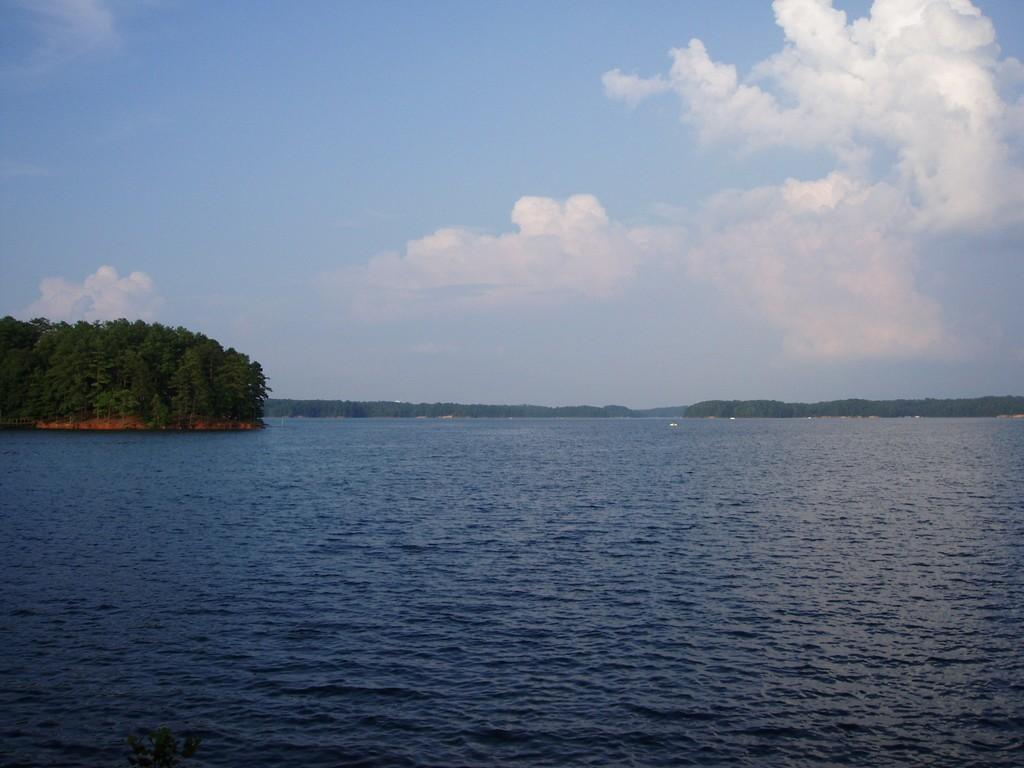What type of natural feature can be seen in the image? There is a river in the image. What is located at the center of the image? There are trees at the center of the image. What can be seen in the background of the image? The sky is visible in the background of the image. What type of organization is depicted in the image? There is no organization depicted in the image; it features a river, trees, and the sky. Can you tell me how many stones are visible in the image? There are no stones present in the image. 